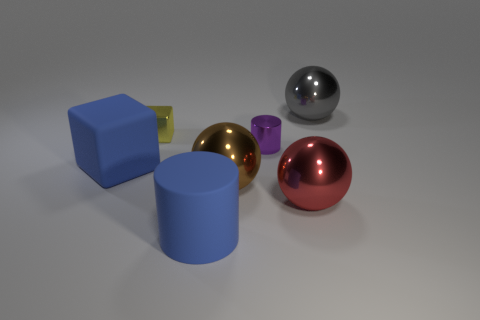How many red things are either spheres or large matte cylinders?
Provide a succinct answer. 1. What number of blue matte things are the same shape as the large red object?
Provide a short and direct response. 0. There is a yellow thing that is the same size as the metallic cylinder; what shape is it?
Offer a very short reply. Cube. There is a brown object; are there any tiny purple things on the left side of it?
Your response must be concise. No. Are there any blue rubber things that are left of the large matte object that is left of the yellow block?
Keep it short and to the point. No. Is the number of shiny balls that are left of the large brown shiny thing less than the number of red metallic things in front of the large red metallic object?
Provide a succinct answer. No. What shape is the purple metal object?
Give a very brief answer. Cylinder. What material is the block left of the small yellow cube?
Provide a short and direct response. Rubber. There is a blue thing that is behind the blue matte thing that is right of the blue matte object behind the large blue cylinder; what size is it?
Provide a succinct answer. Large. Is the cube behind the tiny purple object made of the same material as the sphere that is on the left side of the tiny metal cylinder?
Your answer should be very brief. Yes. 